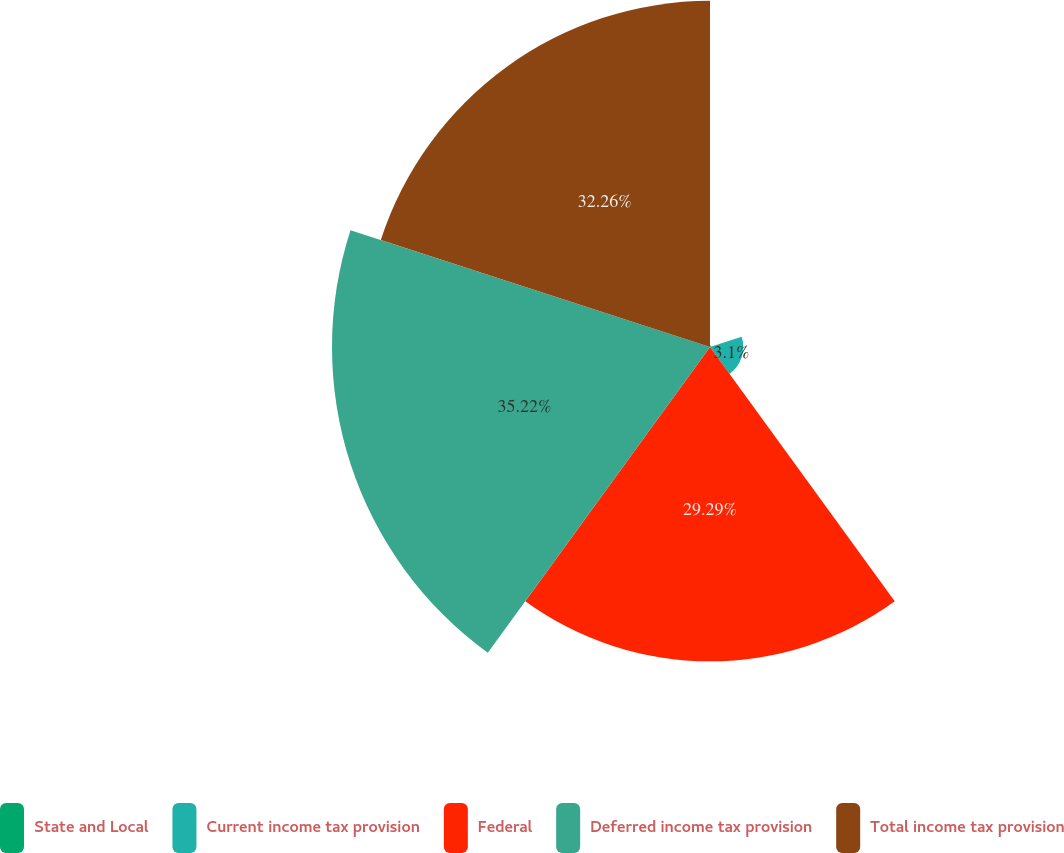Convert chart. <chart><loc_0><loc_0><loc_500><loc_500><pie_chart><fcel>State and Local<fcel>Current income tax provision<fcel>Federal<fcel>Deferred income tax provision<fcel>Total income tax provision<nl><fcel>0.13%<fcel>3.1%<fcel>29.29%<fcel>35.23%<fcel>32.26%<nl></chart> 